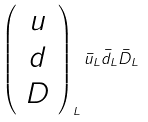<formula> <loc_0><loc_0><loc_500><loc_500>\left ( \begin{array} { c } u \\ d \\ D \end{array} \right ) _ { L } \bar { u } _ { L } \bar { d } _ { L } \bar { D } _ { L }</formula> 